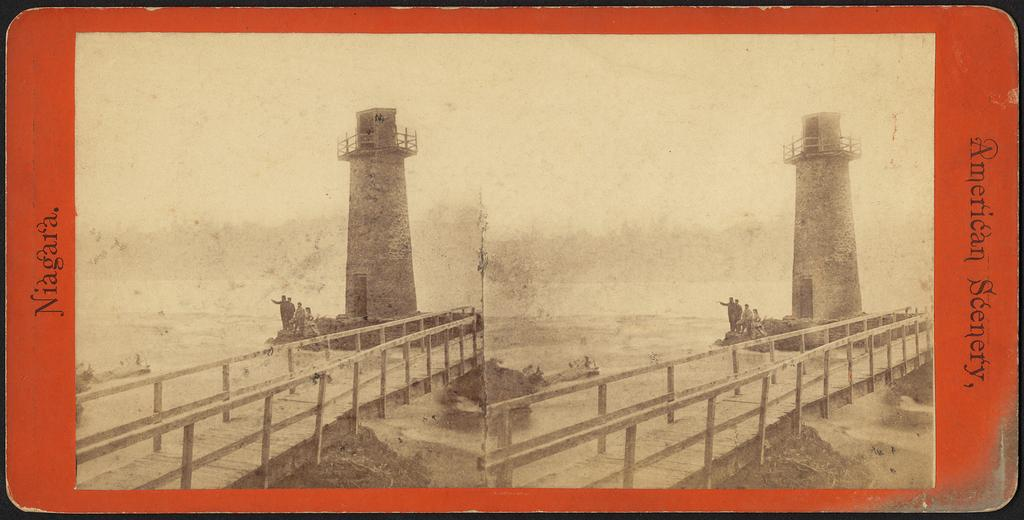<image>
Render a clear and concise summary of the photo. An old photo of Niagara says American Scenery on the side of it. 